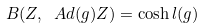<formula> <loc_0><loc_0><loc_500><loc_500>B ( Z , \ A d ( g ) Z ) = \cosh l ( g )</formula> 